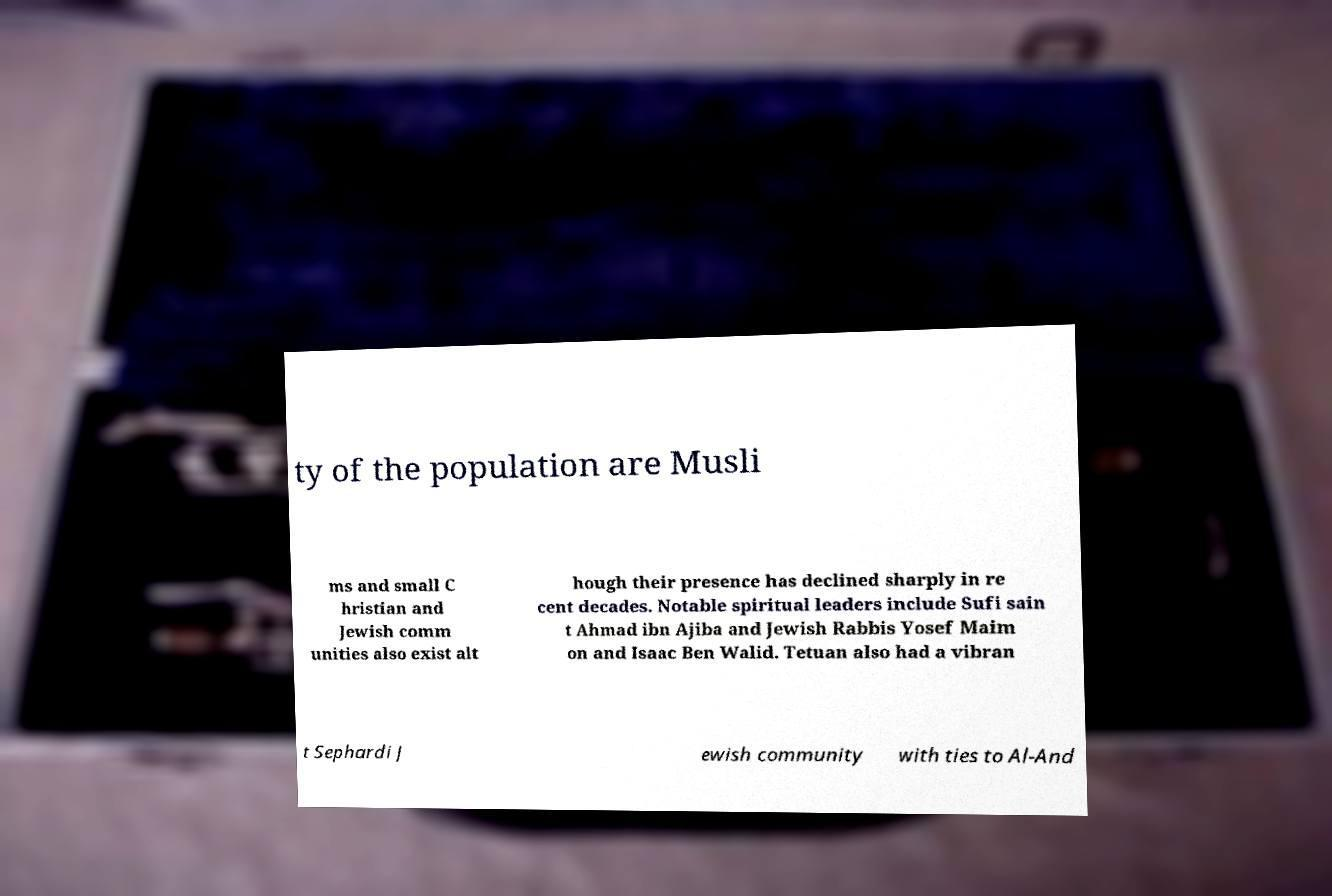Please read and relay the text visible in this image. What does it say? ty of the population are Musli ms and small C hristian and Jewish comm unities also exist alt hough their presence has declined sharply in re cent decades. Notable spiritual leaders include Sufi sain t Ahmad ibn Ajiba and Jewish Rabbis Yosef Maim on and Isaac Ben Walid. Tetuan also had a vibran t Sephardi J ewish community with ties to Al-And 